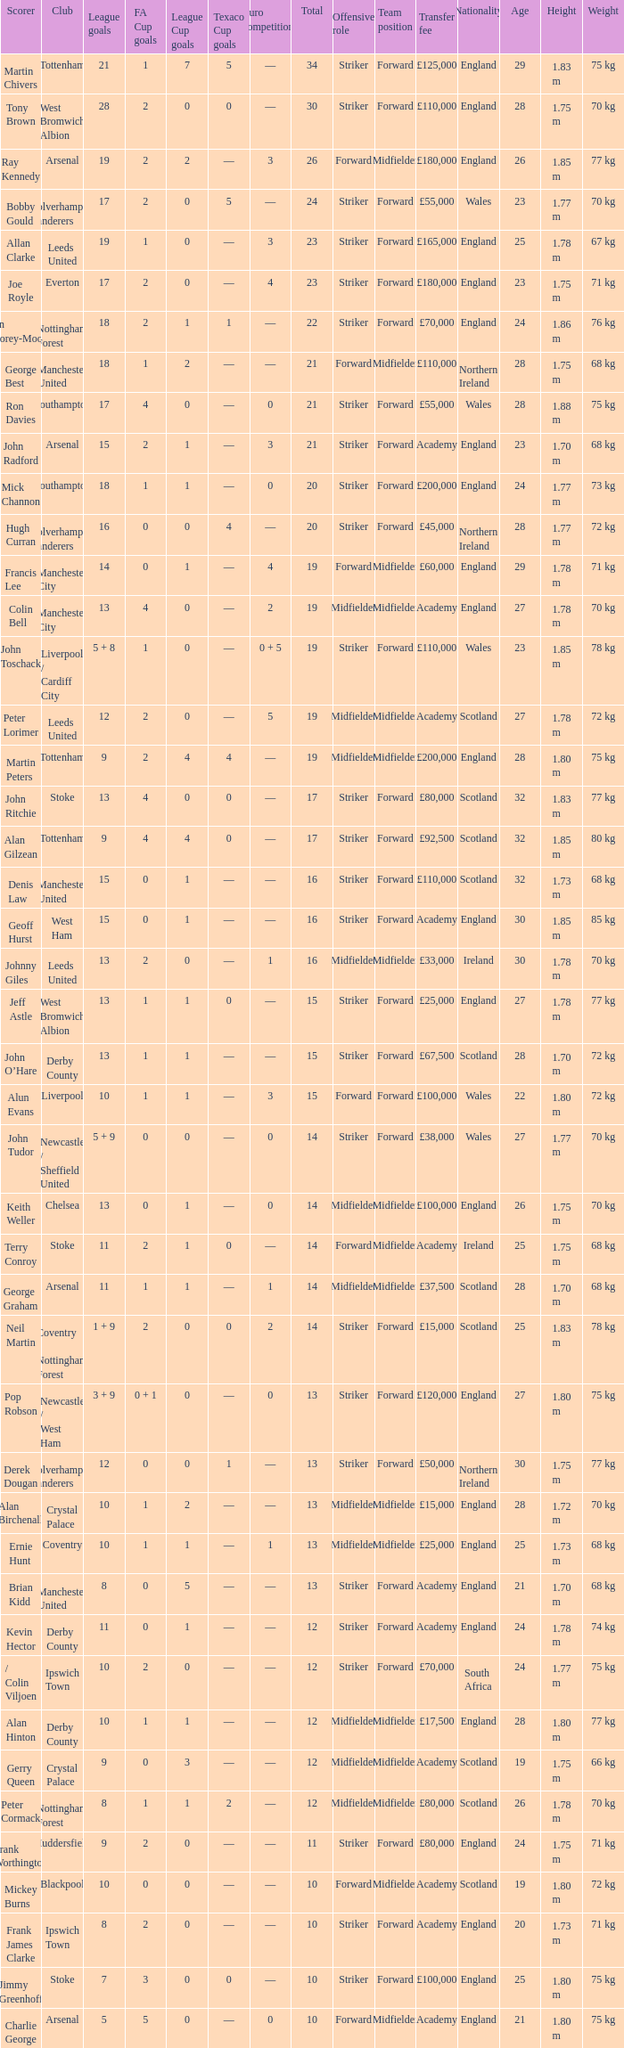What is FA Cup Goals, when Euro Competitions is 1, and when League Goals is 11? 1.0. 